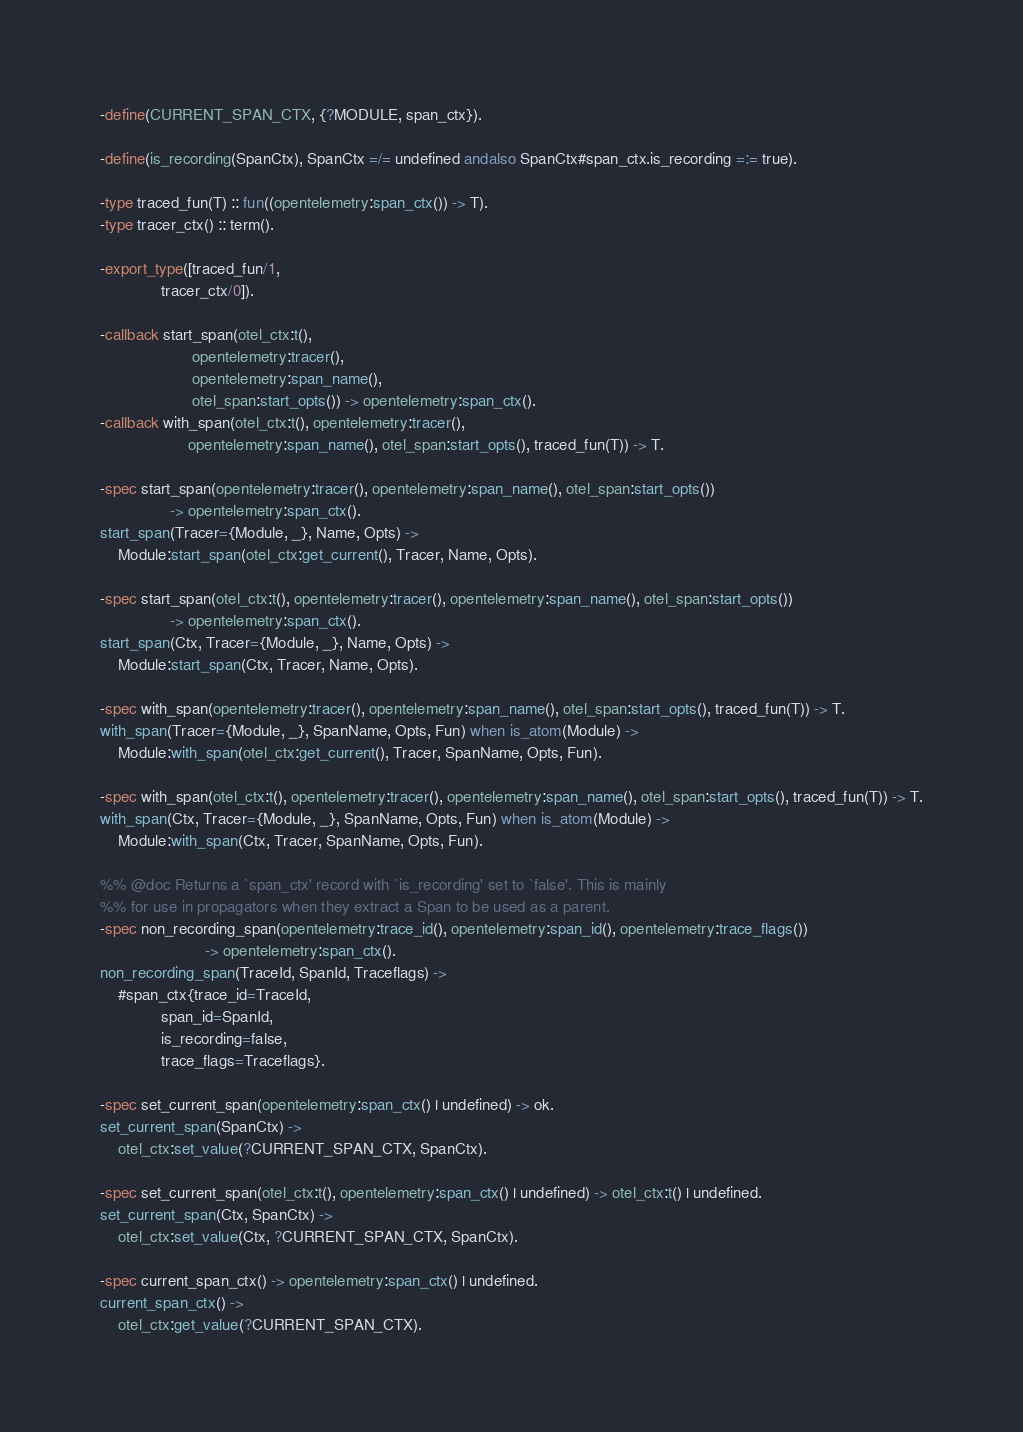Convert code to text. <code><loc_0><loc_0><loc_500><loc_500><_Erlang_>-define(CURRENT_SPAN_CTX, {?MODULE, span_ctx}).

-define(is_recording(SpanCtx), SpanCtx =/= undefined andalso SpanCtx#span_ctx.is_recording =:= true).

-type traced_fun(T) :: fun((opentelemetry:span_ctx()) -> T).
-type tracer_ctx() :: term().

-export_type([traced_fun/1,
              tracer_ctx/0]).

-callback start_span(otel_ctx:t(),
                     opentelemetry:tracer(),
                     opentelemetry:span_name(),
                     otel_span:start_opts()) -> opentelemetry:span_ctx().
-callback with_span(otel_ctx:t(), opentelemetry:tracer(),
                    opentelemetry:span_name(), otel_span:start_opts(), traced_fun(T)) -> T.

-spec start_span(opentelemetry:tracer(), opentelemetry:span_name(), otel_span:start_opts())
                -> opentelemetry:span_ctx().
start_span(Tracer={Module, _}, Name, Opts) ->
    Module:start_span(otel_ctx:get_current(), Tracer, Name, Opts).

-spec start_span(otel_ctx:t(), opentelemetry:tracer(), opentelemetry:span_name(), otel_span:start_opts())
                -> opentelemetry:span_ctx().
start_span(Ctx, Tracer={Module, _}, Name, Opts) ->
    Module:start_span(Ctx, Tracer, Name, Opts).

-spec with_span(opentelemetry:tracer(), opentelemetry:span_name(), otel_span:start_opts(), traced_fun(T)) -> T.
with_span(Tracer={Module, _}, SpanName, Opts, Fun) when is_atom(Module) ->
    Module:with_span(otel_ctx:get_current(), Tracer, SpanName, Opts, Fun).

-spec with_span(otel_ctx:t(), opentelemetry:tracer(), opentelemetry:span_name(), otel_span:start_opts(), traced_fun(T)) -> T.
with_span(Ctx, Tracer={Module, _}, SpanName, Opts, Fun) when is_atom(Module) ->
    Module:with_span(Ctx, Tracer, SpanName, Opts, Fun).

%% @doc Returns a `span_ctx' record with `is_recording' set to `false'. This is mainly
%% for use in propagators when they extract a Span to be used as a parent.
-spec non_recording_span(opentelemetry:trace_id(), opentelemetry:span_id(), opentelemetry:trace_flags())
                        -> opentelemetry:span_ctx().
non_recording_span(TraceId, SpanId, Traceflags) ->
    #span_ctx{trace_id=TraceId,
              span_id=SpanId,
              is_recording=false,
              trace_flags=Traceflags}.

-spec set_current_span(opentelemetry:span_ctx() | undefined) -> ok.
set_current_span(SpanCtx) ->
    otel_ctx:set_value(?CURRENT_SPAN_CTX, SpanCtx).

-spec set_current_span(otel_ctx:t(), opentelemetry:span_ctx() | undefined) -> otel_ctx:t() | undefined.
set_current_span(Ctx, SpanCtx) ->
    otel_ctx:set_value(Ctx, ?CURRENT_SPAN_CTX, SpanCtx).

-spec current_span_ctx() -> opentelemetry:span_ctx() | undefined.
current_span_ctx() ->
    otel_ctx:get_value(?CURRENT_SPAN_CTX).
</code> 